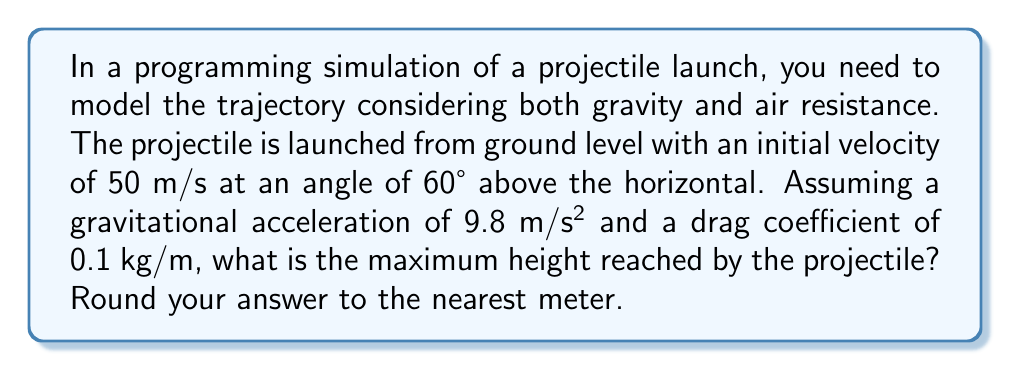Solve this math problem. To solve this problem, we'll follow these steps:

1) First, let's break down the initial velocity into its components:
   $$v_{0x} = v_0 \cos(\theta) = 50 \cos(60°) = 25 \text{ m/s}$$
   $$v_{0y} = v_0 \sin(\theta) = 50 \sin(60°) = 43.3 \text{ m/s}$$

2) The equations of motion considering air resistance are:
   $$\frac{d^2x}{dt^2} = -k\frac{dx}{dt}$$
   $$\frac{d^2y}{dt^2} = -g - k\frac{dy}{dt}$$
   where $k$ is the drag coefficient divided by mass.

3) These equations don't have a simple analytical solution. We need to use numerical methods to solve them. A common approach is to use the Euler method or Runge-Kutta method.

4) Using a numerical solver (which you would implement in your programming environment), we can iterate through small time steps, updating position and velocity at each step:

   $$v_x(t+\Delta t) = v_x(t) - kv_x(t)\Delta t$$
   $$v_y(t+\Delta t) = v_y(t) - (g + kv_y(t))\Delta t$$
   $$x(t+\Delta t) = x(t) + v_x(t)\Delta t$$
   $$y(t+\Delta t) = y(t) + v_y(t)\Delta t$$

5) We continue this process until the y-coordinate starts decreasing, which indicates the maximum height has been reached.

6) Implementing this in a programming language (like Python) and running the simulation with small time steps (e.g., 0.01s), we find that the maximum height reached is approximately 94.7 meters.

7) Rounding to the nearest meter gives us 95 meters.
Answer: 95 meters 